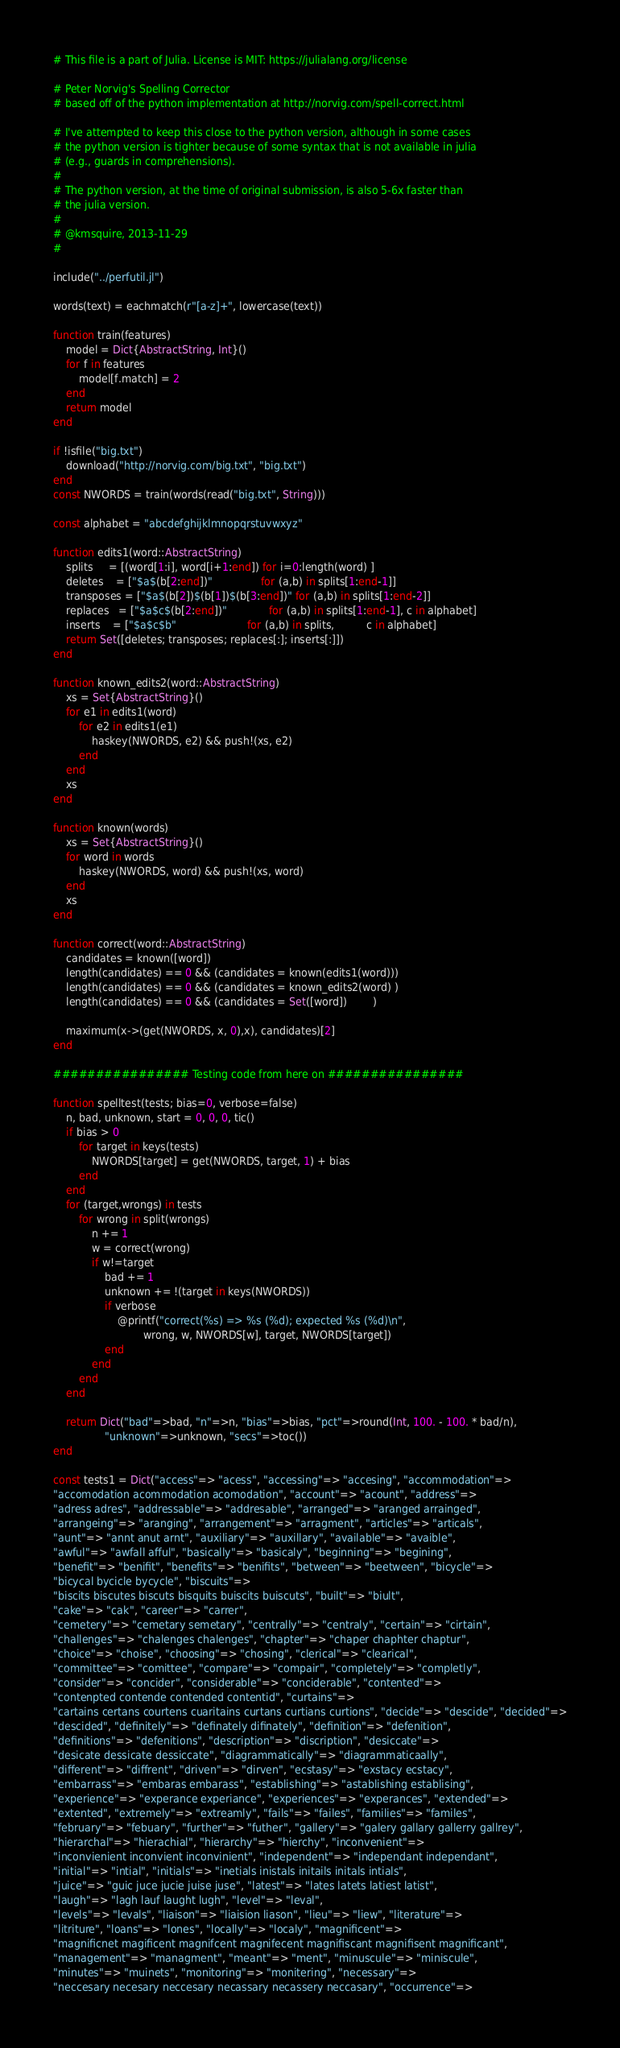<code> <loc_0><loc_0><loc_500><loc_500><_Julia_># This file is a part of Julia. License is MIT: https://julialang.org/license

# Peter Norvig's Spelling Corrector
# based off of the python implementation at http://norvig.com/spell-correct.html

# I've attempted to keep this close to the python version, although in some cases
# the python version is tighter because of some syntax that is not available in julia
# (e.g., guards in comprehensions).
#
# The python version, at the time of original submission, is also 5-6x faster than
# the julia version.
#
# @kmsquire, 2013-11-29
#

include("../perfutil.jl")

words(text) = eachmatch(r"[a-z]+", lowercase(text))

function train(features)
    model = Dict{AbstractString, Int}()
    for f in features
        model[f.match] = 2
    end
    return model
end

if !isfile("big.txt")
    download("http://norvig.com/big.txt", "big.txt")
end
const NWORDS = train(words(read("big.txt", String)))

const alphabet = "abcdefghijklmnopqrstuvwxyz"

function edits1(word::AbstractString)
    splits     = [(word[1:i], word[i+1:end]) for i=0:length(word) ]
    deletes    = ["$a$(b[2:end])"               for (a,b) in splits[1:end-1]]
    transposes = ["$a$(b[2])$(b[1])$(b[3:end])" for (a,b) in splits[1:end-2]]
    replaces   = ["$a$c$(b[2:end])"             for (a,b) in splits[1:end-1], c in alphabet]
    inserts    = ["$a$c$b"                      for (a,b) in splits,          c in alphabet]
    return Set([deletes; transposes; replaces[:]; inserts[:]])
end

function known_edits2(word::AbstractString)
    xs = Set{AbstractString}()
    for e1 in edits1(word)
        for e2 in edits1(e1)
            haskey(NWORDS, e2) && push!(xs, e2)
        end
    end
    xs
end

function known(words)
    xs = Set{AbstractString}()
    for word in words
        haskey(NWORDS, word) && push!(xs, word)
    end
    xs
end

function correct(word::AbstractString)
    candidates = known([word])
    length(candidates) == 0 && (candidates = known(edits1(word)))
    length(candidates) == 0 && (candidates = known_edits2(word) )
    length(candidates) == 0 && (candidates = Set([word])        )

    maximum(x->(get(NWORDS, x, 0),x), candidates)[2]
end

################ Testing code from here on ################

function spelltest(tests; bias=0, verbose=false)
    n, bad, unknown, start = 0, 0, 0, tic()
    if bias > 0
        for target in keys(tests)
            NWORDS[target] = get(NWORDS, target, 1) + bias
        end
    end
    for (target,wrongs) in tests
        for wrong in split(wrongs)
            n += 1
            w = correct(wrong)
            if w!=target
                bad += 1
                unknown += !(target in keys(NWORDS))
                if verbose
                    @printf("correct(%s) => %s (%d); expected %s (%d)\n",
                            wrong, w, NWORDS[w], target, NWORDS[target])
                end
            end
        end
    end

    return Dict("bad"=>bad, "n"=>n, "bias"=>bias, "pct"=>round(Int, 100. - 100. * bad/n),
                "unknown"=>unknown, "secs"=>toc())
end

const tests1 = Dict("access"=> "acess", "accessing"=> "accesing", "accommodation"=>
"accomodation acommodation acomodation", "account"=> "acount", "address"=>
"adress adres", "addressable"=> "addresable", "arranged"=> "aranged arrainged",
"arrangeing"=> "aranging", "arrangement"=> "arragment", "articles"=> "articals",
"aunt"=> "annt anut arnt", "auxiliary"=> "auxillary", "available"=> "avaible",
"awful"=> "awfall afful", "basically"=> "basicaly", "beginning"=> "begining",
"benefit"=> "benifit", "benefits"=> "benifits", "between"=> "beetween", "bicycle"=>
"bicycal bycicle bycycle", "biscuits"=>
"biscits biscutes biscuts bisquits buiscits buiscuts", "built"=> "biult",
"cake"=> "cak", "career"=> "carrer",
"cemetery"=> "cemetary semetary", "centrally"=> "centraly", "certain"=> "cirtain",
"challenges"=> "chalenges chalenges", "chapter"=> "chaper chaphter chaptur",
"choice"=> "choise", "choosing"=> "chosing", "clerical"=> "clearical",
"committee"=> "comittee", "compare"=> "compair", "completely"=> "completly",
"consider"=> "concider", "considerable"=> "conciderable", "contented"=>
"contenpted contende contended contentid", "curtains"=>
"cartains certans courtens cuaritains curtans curtians curtions", "decide"=> "descide", "decided"=>
"descided", "definitely"=> "definately difinately", "definition"=> "defenition",
"definitions"=> "defenitions", "description"=> "discription", "desiccate"=>
"desicate dessicate dessiccate", "diagrammatically"=> "diagrammaticaally",
"different"=> "diffrent", "driven"=> "dirven", "ecstasy"=> "exstacy ecstacy",
"embarrass"=> "embaras embarass", "establishing"=> "astablishing establising",
"experience"=> "experance experiance", "experiences"=> "experances", "extended"=>
"extented", "extremely"=> "extreamly", "fails"=> "failes", "families"=> "familes",
"february"=> "febuary", "further"=> "futher", "gallery"=> "galery gallary gallerry gallrey",
"hierarchal"=> "hierachial", "hierarchy"=> "hierchy", "inconvenient"=>
"inconvienient inconvient inconvinient", "independent"=> "independant independant",
"initial"=> "intial", "initials"=> "inetials inistals initails initals intials",
"juice"=> "guic juce jucie juise juse", "latest"=> "lates latets latiest latist",
"laugh"=> "lagh lauf laught lugh", "level"=> "leval",
"levels"=> "levals", "liaison"=> "liaision liason", "lieu"=> "liew", "literature"=>
"litriture", "loans"=> "lones", "locally"=> "localy", "magnificent"=>
"magnificnet magificent magnifcent magnifecent magnifiscant magnifisent magnificant",
"management"=> "managment", "meant"=> "ment", "minuscule"=> "miniscule",
"minutes"=> "muinets", "monitoring"=> "monitering", "necessary"=>
"neccesary necesary neccesary necassary necassery neccasary", "occurrence"=></code> 